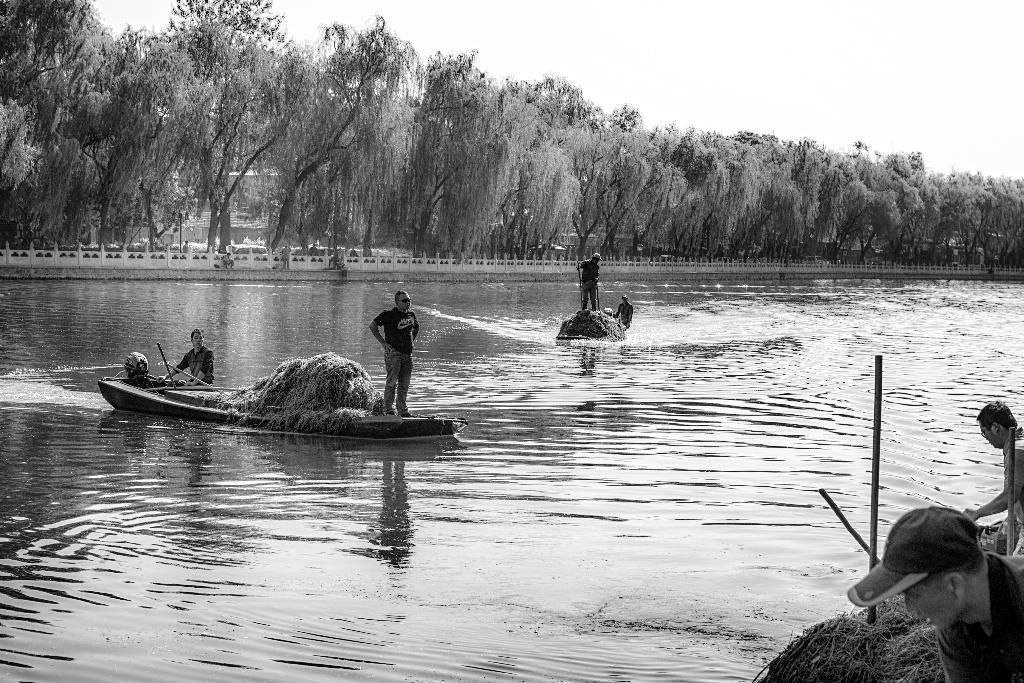What is the man doing in the image? The man is standing on a boat. Where is the boat located? The boat is in the water. What can be seen in the background of the image? There are trees visible in the background of the image. What type of waste can be seen in the image? There is no waste visible in the image. 